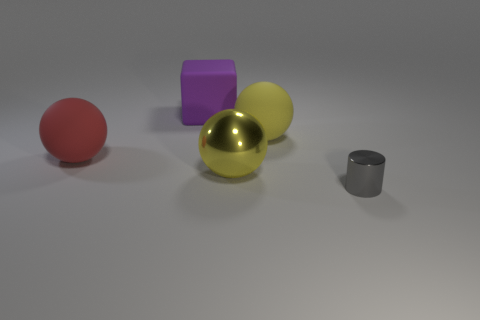Add 4 purple matte objects. How many objects exist? 9 Subtract all cubes. How many objects are left? 4 Add 2 rubber spheres. How many rubber spheres exist? 4 Subtract 0 cyan cylinders. How many objects are left? 5 Subtract all yellow rubber balls. Subtract all big yellow rubber spheres. How many objects are left? 3 Add 4 small shiny objects. How many small shiny objects are left? 5 